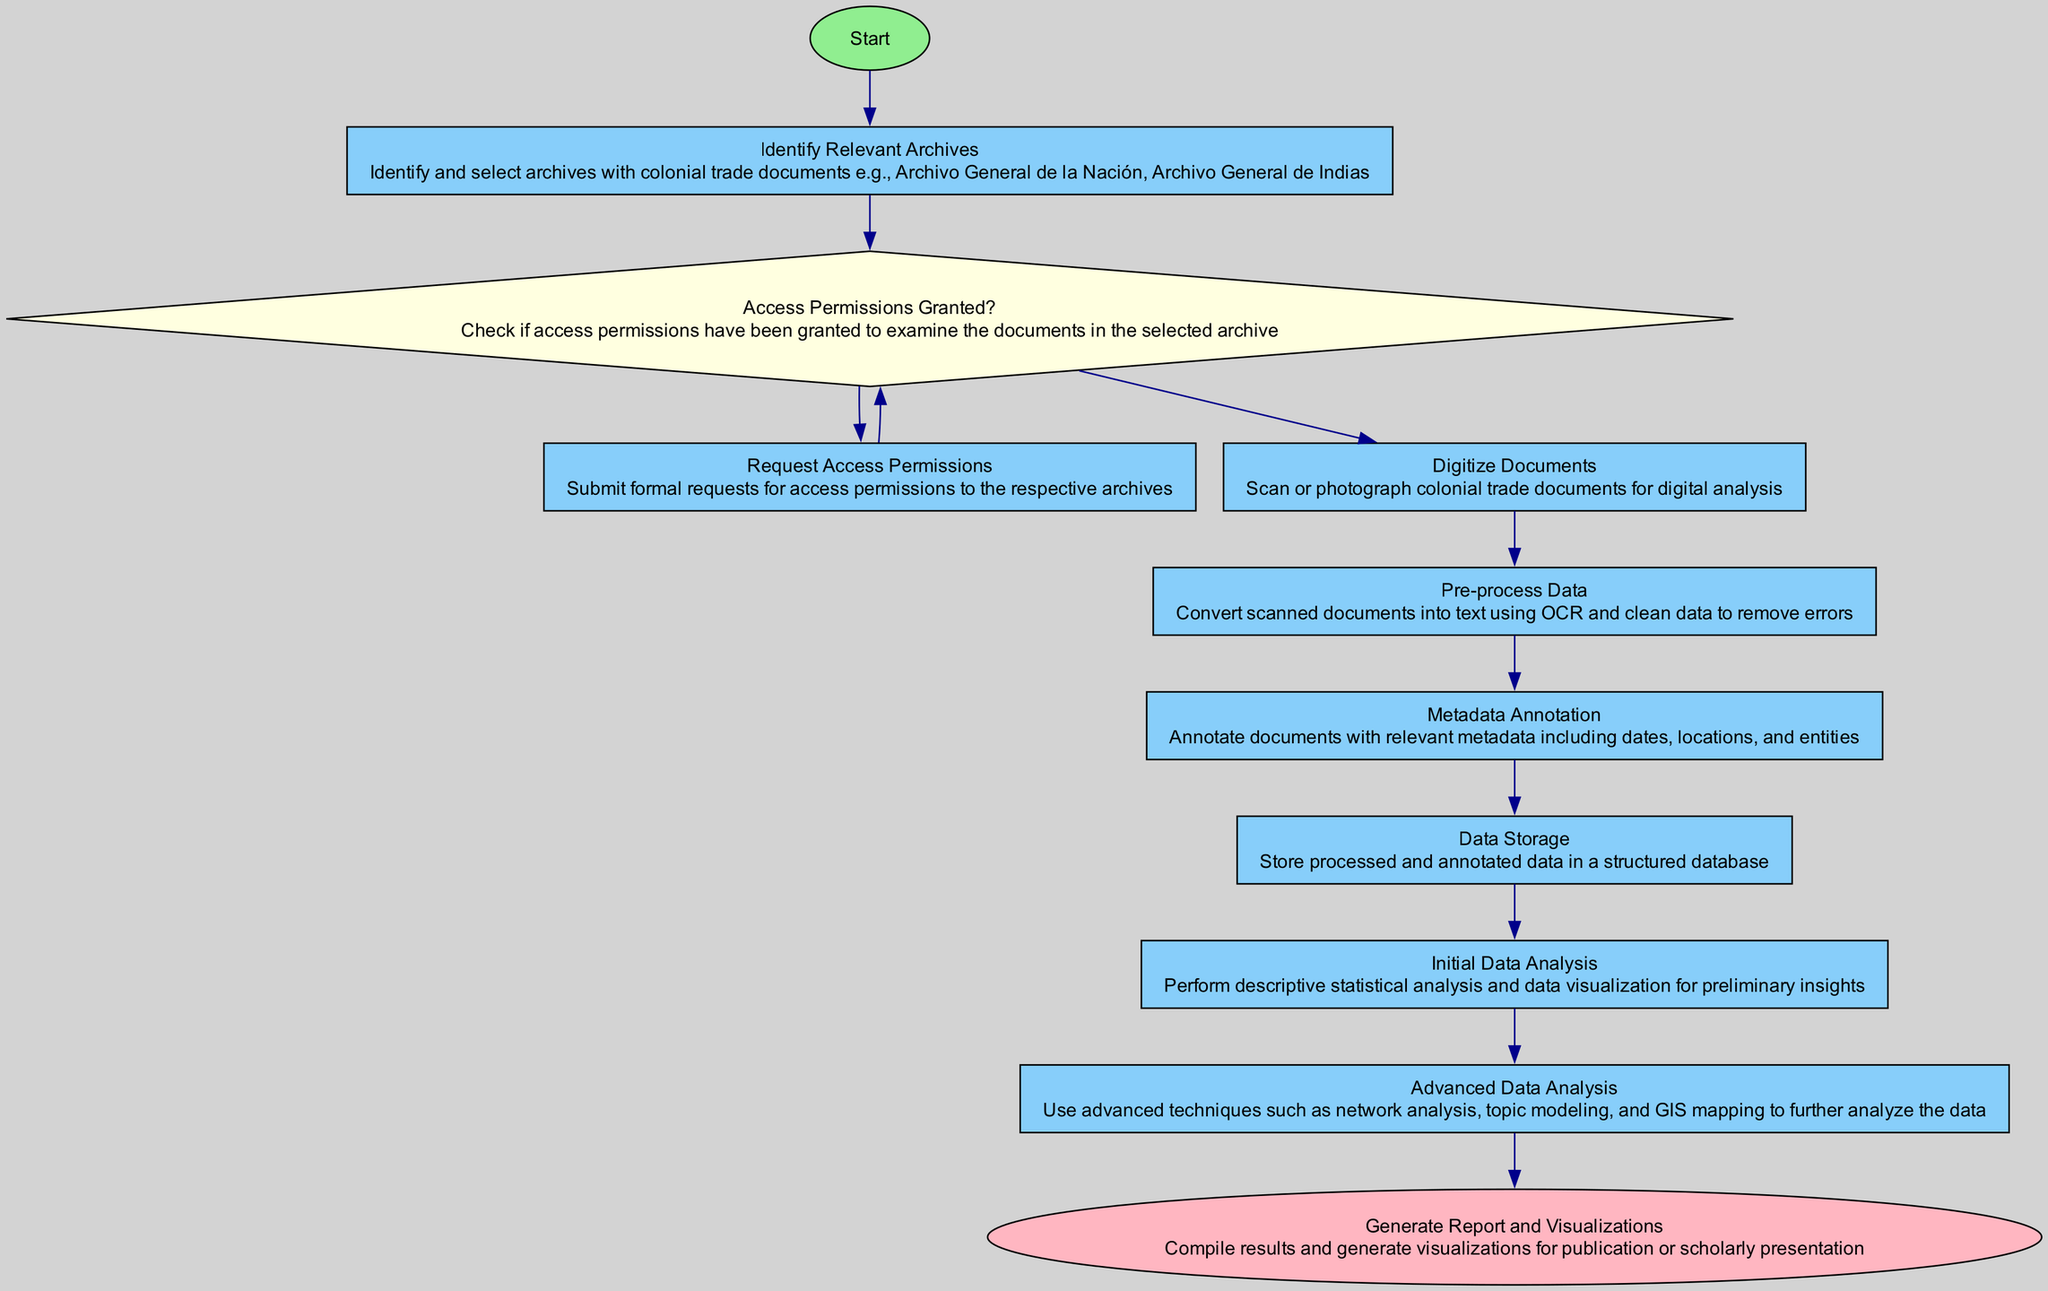What is the first step in the flowchart? The first step is represented by the node with the label "Start." This indicates the beginning of the process.
Answer: Start How many processes are there in the diagram? To find the total number of processes, we count the nodes labeled as "Process." There are six such nodes in the flowchart.
Answer: Six What decision point is present in the flowchart? The diagram includes one decision node labeled "Access Permissions Granted?" which checks if permissions to examine the documents are granted.
Answer: Access Permissions Granted? Which node follows "Digitize Documents"? The node labeled "Pre-process Data" comes directly after "Digitize Documents," indicating the next step in the process sequence.
Answer: Pre-process Data What happens if access permissions are not granted? According to the flowchart, if access permissions are not granted, the process loops back to "Request Access Permissions," indicating that formal requests must be submitted again.
Answer: Request Access Permissions What type of analysis is performed before advanced data analysis? "Initial Data Analysis" is performed before "Advanced Data Analysis," which involves descriptive statistical analysis and data visualization for preliminary insights.
Answer: Initial Data Analysis What is the final output of the process? The last step in the flowchart is labeled "Generate Report and Visualizations," which signifies the compilation of results and the creation of visualizations.
Answer: Generate Report and Visualizations How many nodes are connected to the "Process" node regarding data storage? The "Data Storage" node has only one outgoing connection, which leads to the next process, "Initial Data Analysis." Thus, it is directly connected to one node.
Answer: One 